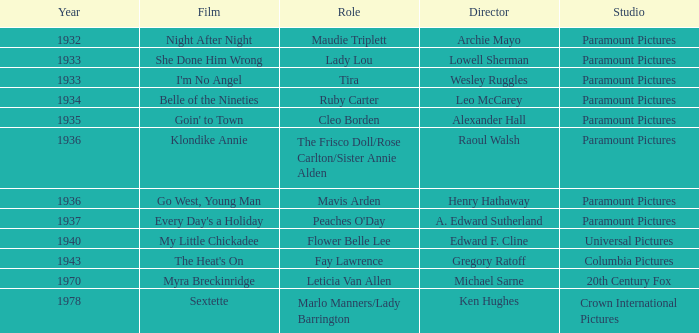What is the Studio of the Film with Director Gregory Ratoff after 1933? Columbia Pictures. 